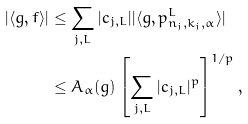Convert formula to latex. <formula><loc_0><loc_0><loc_500><loc_500>| \langle g , f \rangle | & \leq \sum _ { j , L } | c _ { j , L } | | \langle g , p ^ { L } _ { n _ { j } , k _ { j } , \alpha } \rangle | \\ & \leq A _ { \alpha } ( g ) \left [ \sum _ { j , L } | c _ { j , L } | ^ { p } \right ] ^ { 1 / p } ,</formula> 